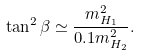<formula> <loc_0><loc_0><loc_500><loc_500>\tan ^ { 2 } \beta \simeq \frac { m _ { H _ { 1 } } ^ { 2 } } { 0 . 1 m _ { H _ { 2 } } ^ { 2 } } .</formula> 